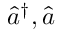<formula> <loc_0><loc_0><loc_500><loc_500>\hat { a } ^ { \dag } , \hat { a }</formula> 